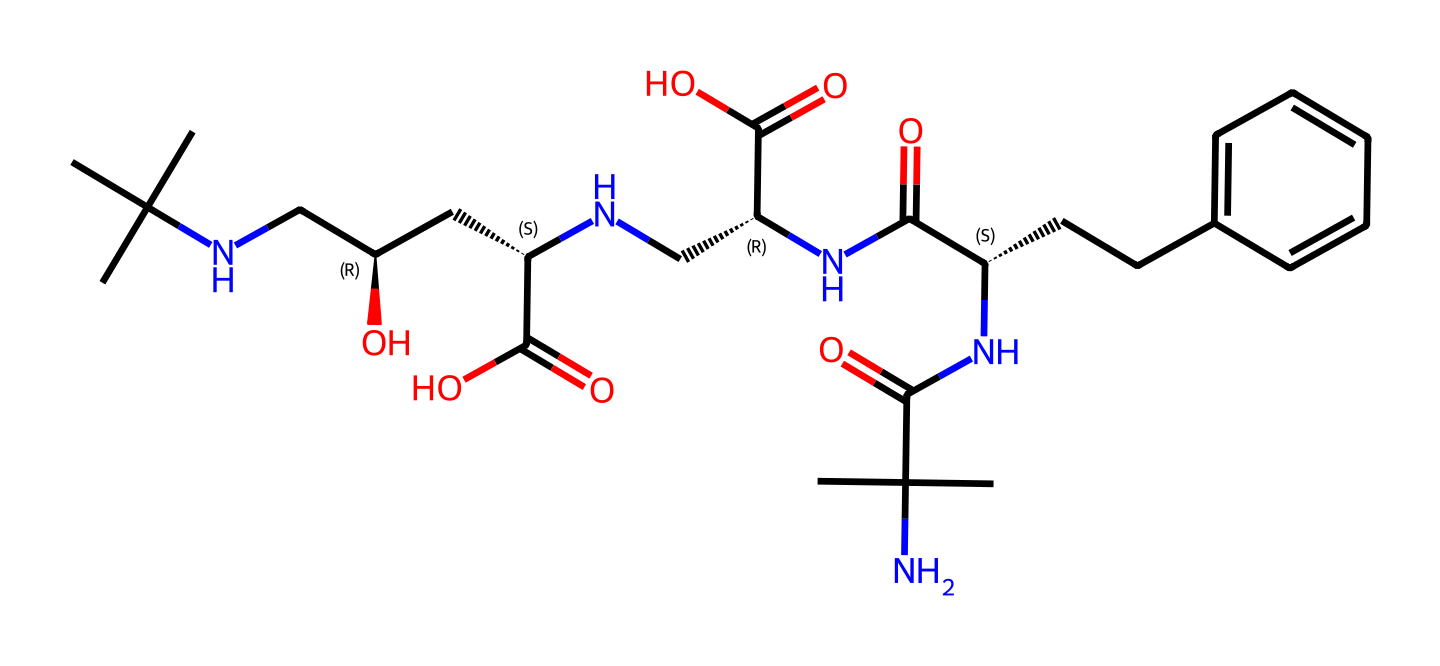What is the molecular formula of lisinopril? By analyzing the SMILES representation, we can determine the elemental composition. Counting the atoms from the SMILES string, we find that there are 21 carbon (C) atoms, 38 hydrogen (H) atoms, 4 nitrogen (N) atoms, and 5 oxygen (O) atoms, leading to the molecular formula C21H38N4O5.
Answer: C21H38N4O5 How many nitrogen atoms are in lisinopril? From the molecular structure expressed in the SMILES notation, we can identify the number of nitrogen (N) atoms present. The string shows four specific locations where nitrogen is represented, confirming that there are four nitrogen atoms in lisinopril.
Answer: 4 What type of molecule is lisinopril classified as? Given the structure of lisinopril, which contains amine and carboxylic acid functional groups along with a peptide bond, it can be classified as a peptide. This classification is due to its multiple amino acid-like structures leading to peptide characteristics.
Answer: peptide How many stereocenters are present in lisinopril? Stereocenters are identified by the chiral centers in the structure, which are marked with the '@' symbol in the SMILES. There are three '@' symbols in the SMILES representation, indicating three stereocenters in the lisinopril molecule.
Answer: 3 What functional groups are present in lisinopril? By examining the SMILES structure, we can identify the functional groups present. Key groups include amines (–NH2), carboxylic acids (–COOH), and an amide linkage (–C(N)–O–). The presence of these groups indicates its biochemical activity.
Answer: amine, carboxylic acid, amide What is the significance of lisinopril being an ACE inhibitor? Lisinopril's structure includes a unique arrangement of atoms that enables it to bind to Angiotensin-Converting Enzyme (ACE), inhibiting its action and leading to decreased blood pressure. This mechanism is critical in treating hypertension.
Answer: lowers blood pressure 